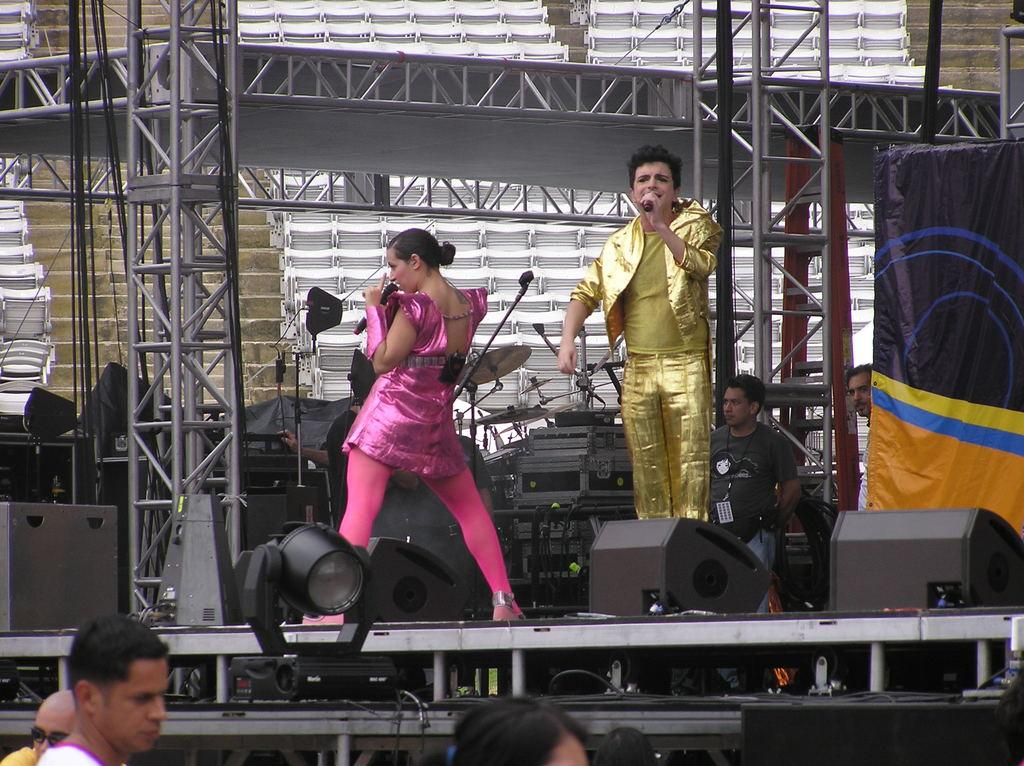What can be seen in the image involving a group of people? There is a group of people in the image, and another group of people can also be seen. What equipment is present in the image related to sound? There are speakers in the image. What type of lighting is present in the image? There is a focus light and a lighting truss in the image. What musical instrument can be seen on the stage? There are cymbals with cymbal stands on the stage. What type of seating is available in the image? There are chairs in the image. What architectural feature is present in the image? There are stairs in the image. What type of treatment is being administered to the library in the image? There is no library present in the image, and therefore no treatment is being administered. How many folds can be seen in the image? There is no foldable object present in the image, so it is not possible to count any folds. 